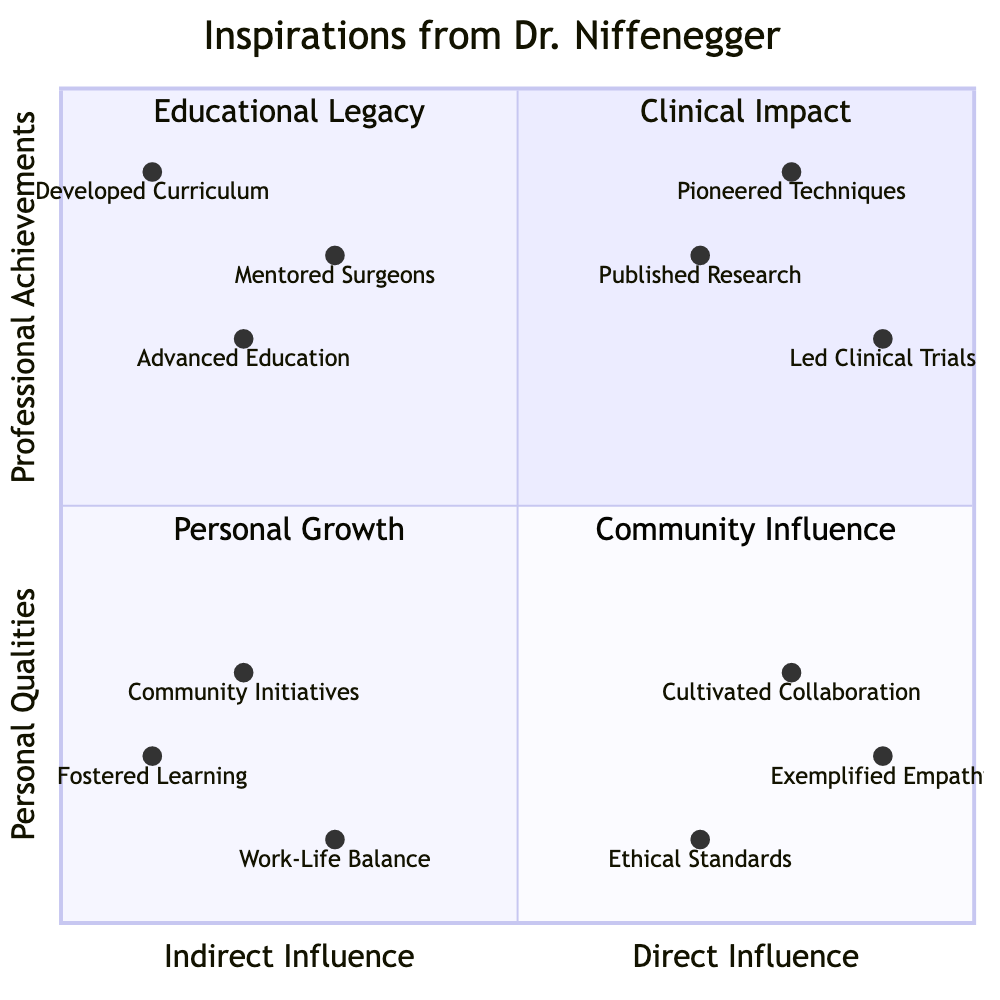What is the highest value in the quadrant for Direct Influence? The highest point on the x-axis for Direct Influence is "Pioneered Pediatric Cardiology Techniques", with a value of 0.8.
Answer: Pioneered Pediatric Cardiology Techniques Which node has the lowest value in the quadrant? The node with the lowest value is "Work-Life Balance", which has a value of 0.1 on both axes.
Answer: Work-Life Balance In which quadrant is "Published Pivotal Research in JAMA" located? "Published Pivotal Research in JAMA" is located in Quadrant 1, as it has a high value for Professional Achievements and a moderate value for Direct Influence.
Answer: Quadrant 1 How many nodes are present in the Community Influence quadrant? The Community Influence quadrant contains 3 nodes: "Community Initiatives", "Fostered Learning", and "Work-Life Balance".
Answer: 3 Which qualities exemplify the highest levels of Personal Growth? The qualities that exemplify the highest Personal Growth are "Exemplified Empathy in Patient Care", with a value of 0.9, and "Cultivated Team Collaboration", with a value of 0.8.
Answer: Exemplified Empathy, Cultivated Collaboration What is the relationship between "Led Innovative Clinical Trials at Johns Hopkins" and "Mentored Leading Cardiac Surgeons"? "Led Innovative Clinical Trials at Johns Hopkins" is situated at a higher value relative to "Mentored Leading Cardiac Surgeons", meaning it is perceived as more impactful in terms of Direct Influence and Professional Achievements.
Answer: Higher value Which node represents the highest Direct Influence in Clinical Impact? The node representing the highest Direct Influence in Clinical Impact is "Led Innovative Clinical Trials at Johns Hopkins", with a value of 0.9.
Answer: Led Innovative Clinical Trials Where is "Advanced Medical Education through Keynote Speeches" positioned in relation to "Developed Curriculum at Top Medical Schools"? "Advanced Medical Education through Keynote Speeches" is positioned above "Developed Curriculum at Top Medical Schools", indicating a higher value in Professional Achievements, showing its greater influence.
Answer: Above Which quadrant includes the majority of nodes focused on Personal Qualities? The quadrant that includes the majority of nodes focused on Personal Qualities is Quadrant 3, containing three nodes related to personal qualities.
Answer: Quadrant 3 